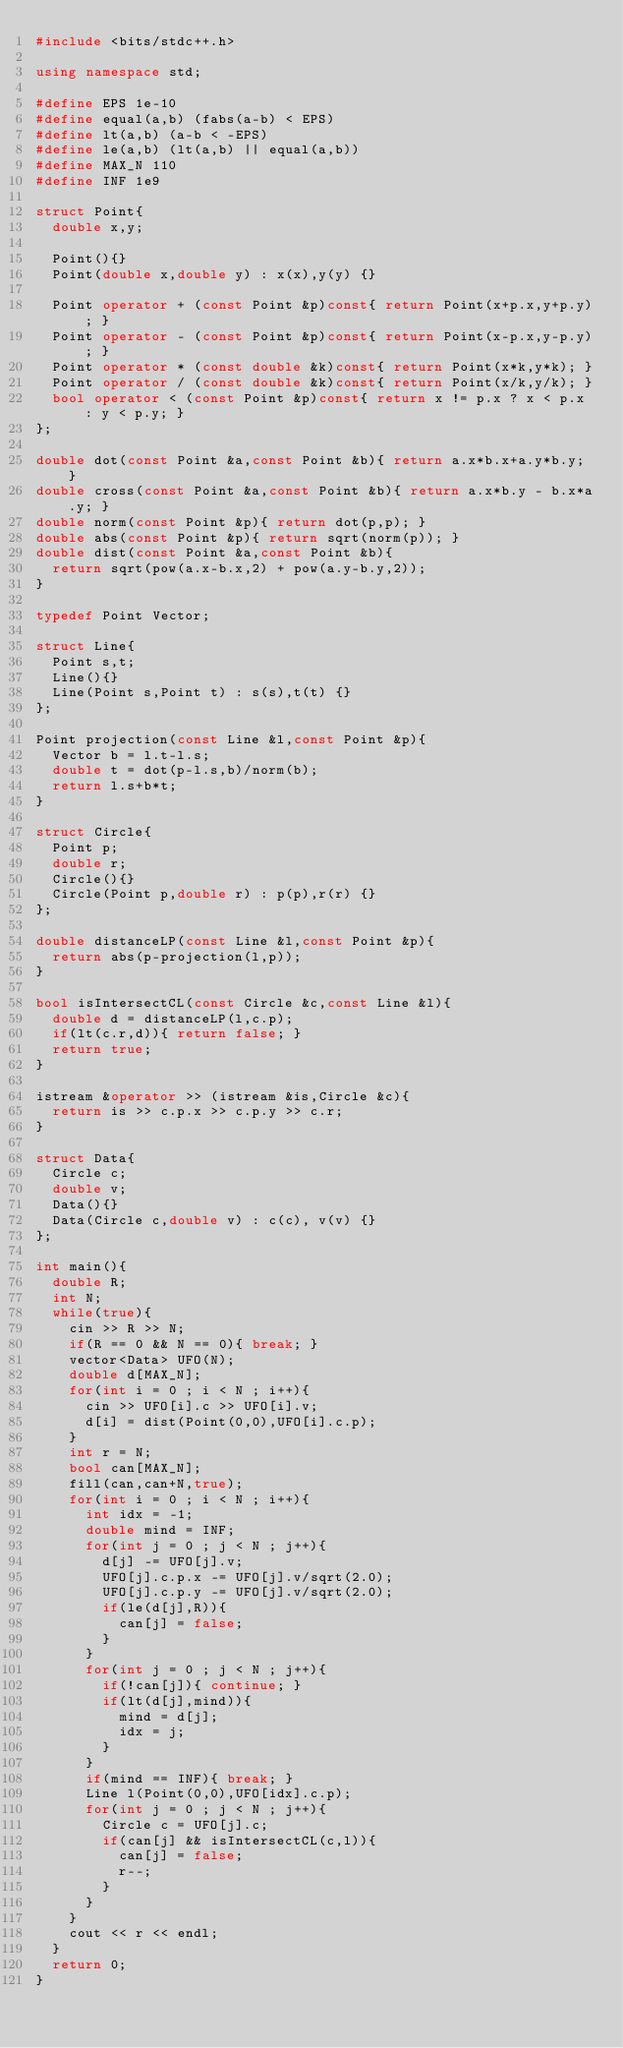Convert code to text. <code><loc_0><loc_0><loc_500><loc_500><_C++_>#include <bits/stdc++.h>

using namespace std;

#define EPS 1e-10
#define equal(a,b) (fabs(a-b) < EPS)
#define lt(a,b) (a-b < -EPS)
#define le(a,b) (lt(a,b) || equal(a,b))
#define MAX_N 110
#define INF 1e9

struct Point{
  double x,y;

  Point(){}
  Point(double x,double y) : x(x),y(y) {}

  Point operator + (const Point &p)const{ return Point(x+p.x,y+p.y); }
  Point operator - (const Point &p)const{ return Point(x-p.x,y-p.y); }
  Point operator * (const double &k)const{ return Point(x*k,y*k); }
  Point operator / (const double &k)const{ return Point(x/k,y/k); }
  bool operator < (const Point &p)const{ return x != p.x ? x < p.x : y < p.y; }
};

double dot(const Point &a,const Point &b){ return a.x*b.x+a.y*b.y; }
double cross(const Point &a,const Point &b){ return a.x*b.y - b.x*a.y; }
double norm(const Point &p){ return dot(p,p); }
double abs(const Point &p){ return sqrt(norm(p)); }
double dist(const Point &a,const Point &b){
  return sqrt(pow(a.x-b.x,2) + pow(a.y-b.y,2));
}

typedef Point Vector;

struct Line{
  Point s,t;
  Line(){}
  Line(Point s,Point t) : s(s),t(t) {}
};

Point projection(const Line &l,const Point &p){
  Vector b = l.t-l.s;
  double t = dot(p-l.s,b)/norm(b);
  return l.s+b*t;
}

struct Circle{
  Point p;
  double r;
  Circle(){}
  Circle(Point p,double r) : p(p),r(r) {}
};

double distanceLP(const Line &l,const Point &p){
  return abs(p-projection(l,p));
}

bool isIntersectCL(const Circle &c,const Line &l){
  double d = distanceLP(l,c.p);
  if(lt(c.r,d)){ return false; }
  return true;
}

istream &operator >> (istream &is,Circle &c){
  return is >> c.p.x >> c.p.y >> c.r;
}

struct Data{
  Circle c;
  double v;
  Data(){}
  Data(Circle c,double v) : c(c), v(v) {}
};

int main(){
  double R;
  int N;
  while(true){
    cin >> R >> N;
    if(R == 0 && N == 0){ break; }
    vector<Data> UFO(N);
    double d[MAX_N];
    for(int i = 0 ; i < N ; i++){
      cin >> UFO[i].c >> UFO[i].v;
      d[i] = dist(Point(0,0),UFO[i].c.p);
    }
    int r = N;
    bool can[MAX_N];
    fill(can,can+N,true);
    for(int i = 0 ; i < N ; i++){
      int idx = -1;
      double mind = INF;
      for(int j = 0 ; j < N ; j++){
        d[j] -= UFO[j].v;
        UFO[j].c.p.x -= UFO[j].v/sqrt(2.0);
        UFO[j].c.p.y -= UFO[j].v/sqrt(2.0);
        if(le(d[j],R)){
          can[j] = false;
        }
      }
      for(int j = 0 ; j < N ; j++){
        if(!can[j]){ continue; }
        if(lt(d[j],mind)){
          mind = d[j];
          idx = j;
        }
      }
      if(mind == INF){ break; }
      Line l(Point(0,0),UFO[idx].c.p);
      for(int j = 0 ; j < N ; j++){
        Circle c = UFO[j].c;
        if(can[j] && isIntersectCL(c,l)){
          can[j] = false;
          r--;
        }
      }
    }
    cout << r << endl;
  }
  return 0;
}</code> 